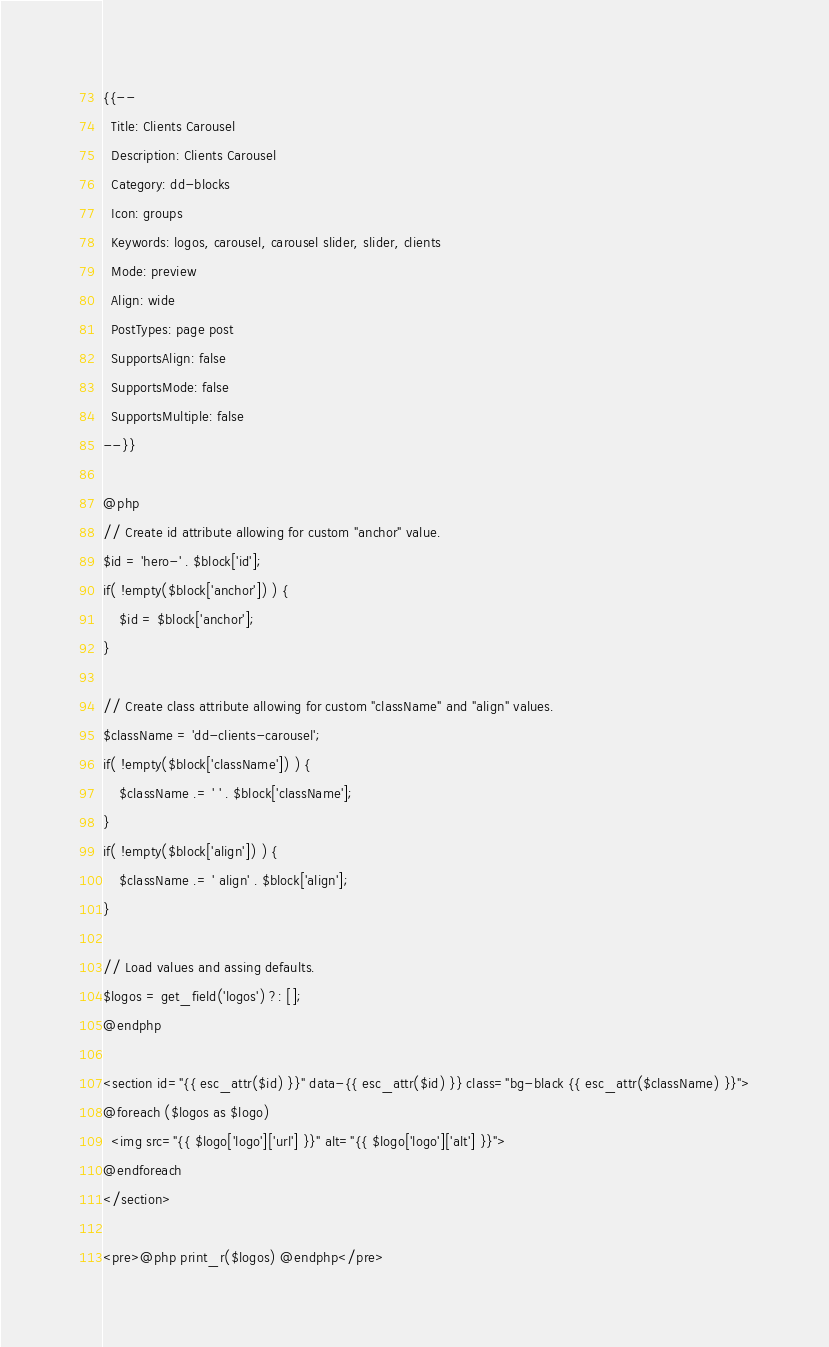Convert code to text. <code><loc_0><loc_0><loc_500><loc_500><_PHP_>{{--
  Title: Clients Carousel
  Description: Clients Carousel
  Category: dd-blocks
  Icon: groups
  Keywords: logos, carousel, carousel slider, slider, clients
  Mode: preview
  Align: wide
  PostTypes: page post
  SupportsAlign: false
  SupportsMode: false
  SupportsMultiple: false
--}}

@php
// Create id attribute allowing for custom "anchor" value.
$id = 'hero-' . $block['id'];
if( !empty($block['anchor']) ) {
    $id = $block['anchor'];
}

// Create class attribute allowing for custom "className" and "align" values.
$className = 'dd-clients-carousel';
if( !empty($block['className']) ) {
    $className .= ' ' . $block['className'];
}
if( !empty($block['align']) ) {
    $className .= ' align' . $block['align'];
}

// Load values and assing defaults.
$logos = get_field('logos') ?: [];
@endphp

<section id="{{ esc_attr($id) }}" data-{{ esc_attr($id) }} class="bg-black {{ esc_attr($className) }}">
@foreach ($logos as $logo)
  <img src="{{ $logo['logo']['url'] }}" alt="{{ $logo['logo']['alt'] }}">
@endforeach
</section>

<pre>@php print_r($logos) @endphp</pre>
</code> 